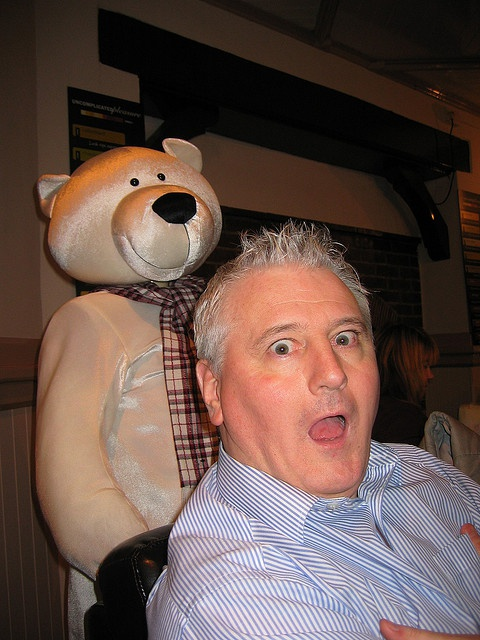Describe the objects in this image and their specific colors. I can see people in black, salmon, lightgray, darkgray, and brown tones, teddy bear in black, tan, and gray tones, tie in black, maroon, and brown tones, people in black, maroon, and brown tones, and chair in black, gray, and maroon tones in this image. 